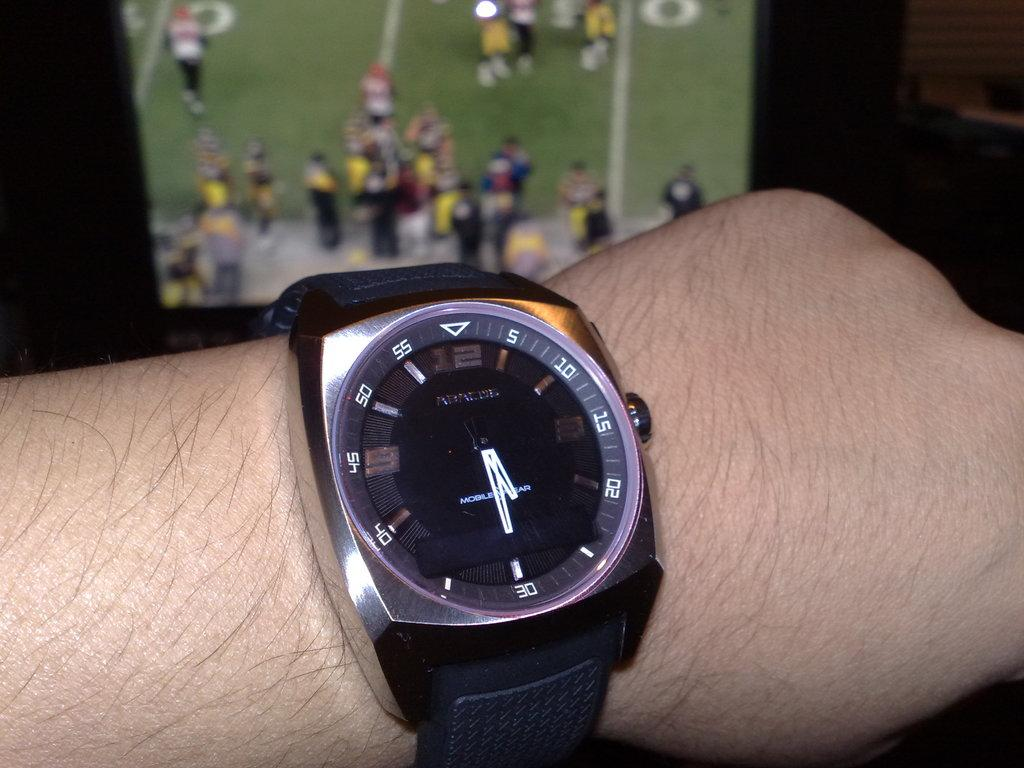<image>
Write a terse but informative summary of the picture. An ABACUS watch in front of a football game on TV. 